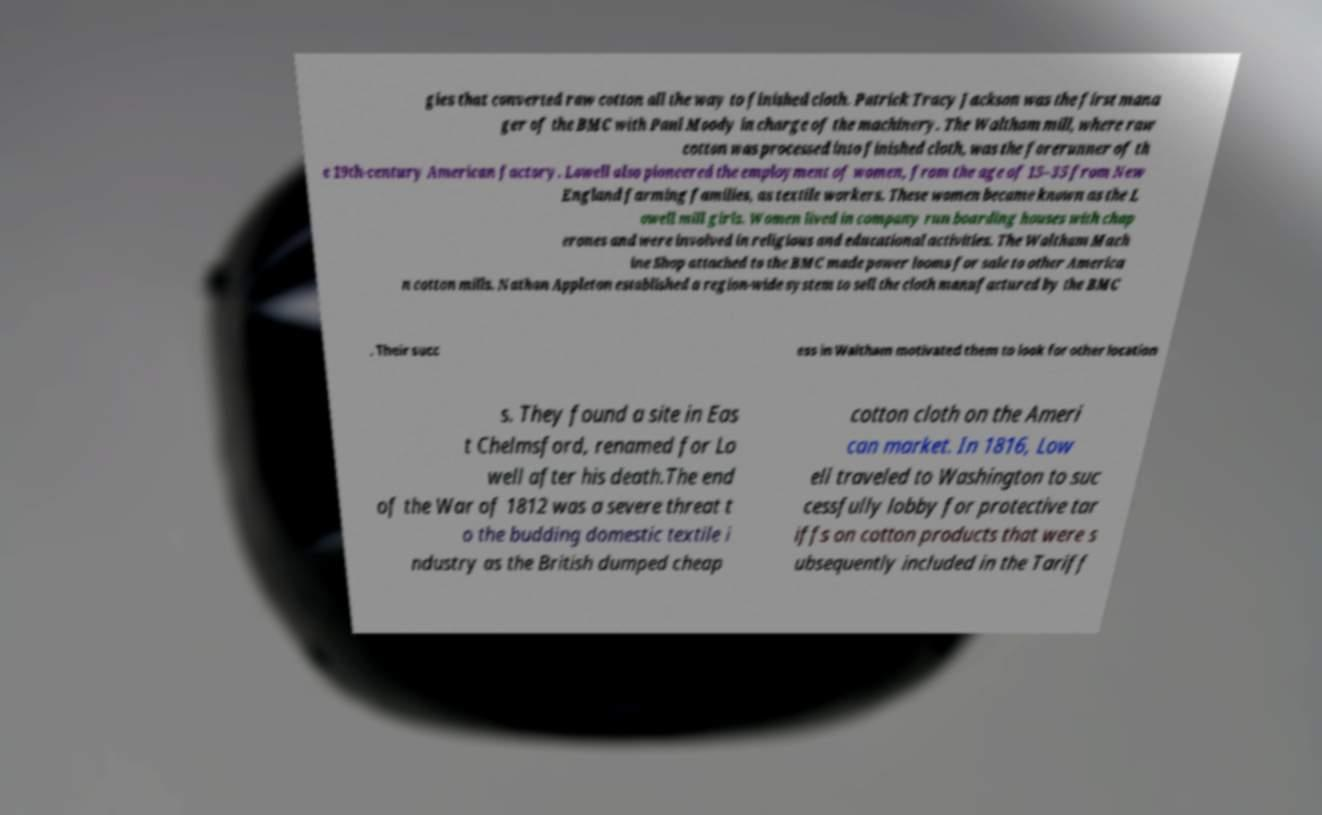Please read and relay the text visible in this image. What does it say? gies that converted raw cotton all the way to finished cloth. Patrick Tracy Jackson was the first mana ger of the BMC with Paul Moody in charge of the machinery. The Waltham mill, where raw cotton was processed into finished cloth, was the forerunner of th e 19th-century American factory. Lowell also pioneered the employment of women, from the age of 15–35 from New England farming families, as textile workers. These women became known as the L owell mill girls. Women lived in company run boarding houses with chap erones and were involved in religious and educational activities. The Waltham Mach ine Shop attached to the BMC made power looms for sale to other America n cotton mills. Nathan Appleton established a region-wide system to sell the cloth manufactured by the BMC . Their succ ess in Waltham motivated them to look for other location s. They found a site in Eas t Chelmsford, renamed for Lo well after his death.The end of the War of 1812 was a severe threat t o the budding domestic textile i ndustry as the British dumped cheap cotton cloth on the Ameri can market. In 1816, Low ell traveled to Washington to suc cessfully lobby for protective tar iffs on cotton products that were s ubsequently included in the Tariff 